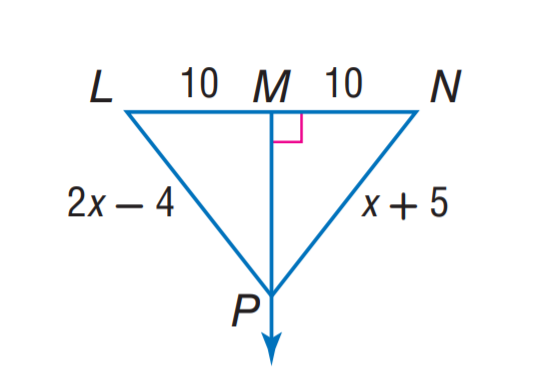Answer the mathemtical geometry problem and directly provide the correct option letter.
Question: Find N P.
Choices: A: 4 B: 7 C: 10 D: 14 D 